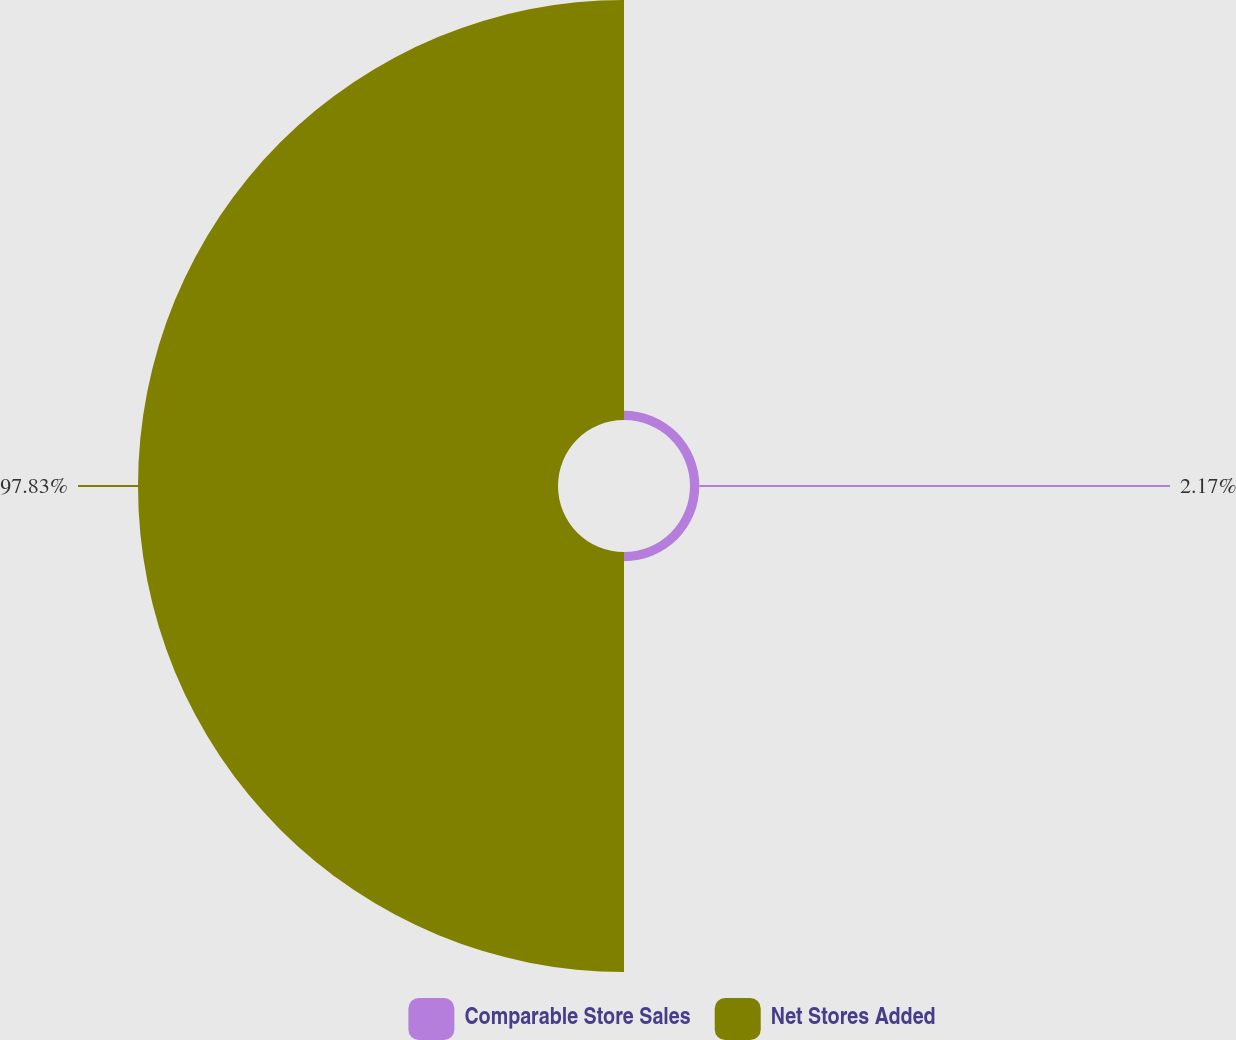<chart> <loc_0><loc_0><loc_500><loc_500><pie_chart><fcel>Comparable Store Sales<fcel>Net Stores Added<nl><fcel>2.17%<fcel>97.83%<nl></chart> 